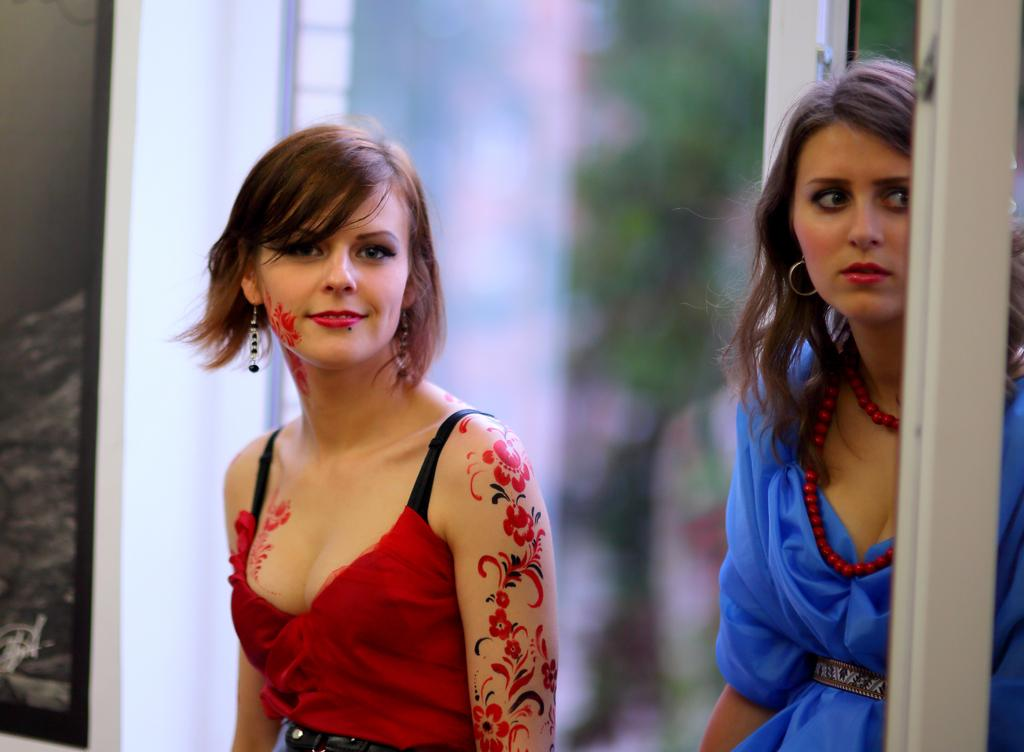How many people are in the image? There are two people in the image. What are the people doing in the image? The people are standing. What colors are the dresses worn by the people in the image? One person is wearing a red dress, one person is wearing a black dress, and one person is wearing a blue dress. Can you describe the background of the image? The background of the image is blurred. What day of the week is depicted in the image? The image does not depict a specific day of the week. Can you describe the rake that is being used by one of the people in the image? There is no rake present in the image. 